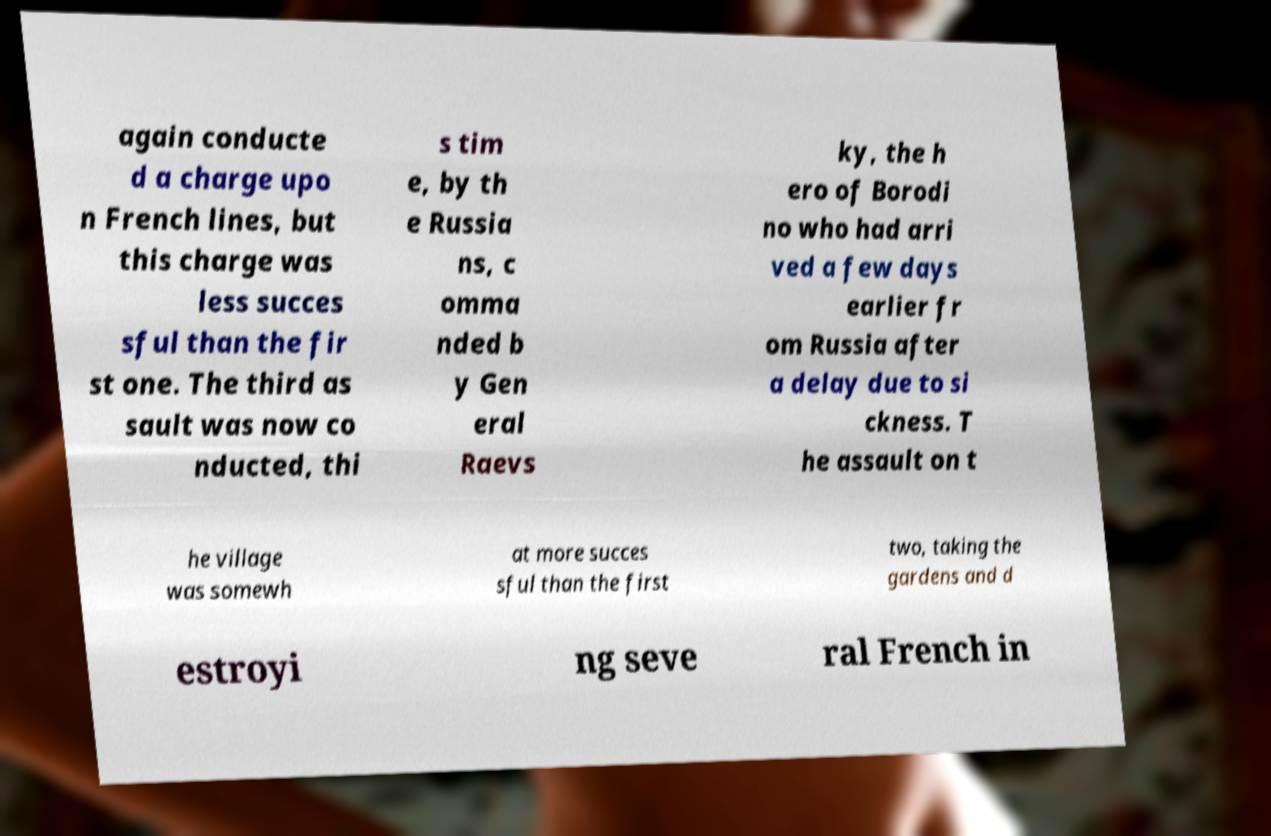Can you accurately transcribe the text from the provided image for me? again conducte d a charge upo n French lines, but this charge was less succes sful than the fir st one. The third as sault was now co nducted, thi s tim e, by th e Russia ns, c omma nded b y Gen eral Raevs ky, the h ero of Borodi no who had arri ved a few days earlier fr om Russia after a delay due to si ckness. T he assault on t he village was somewh at more succes sful than the first two, taking the gardens and d estroyi ng seve ral French in 